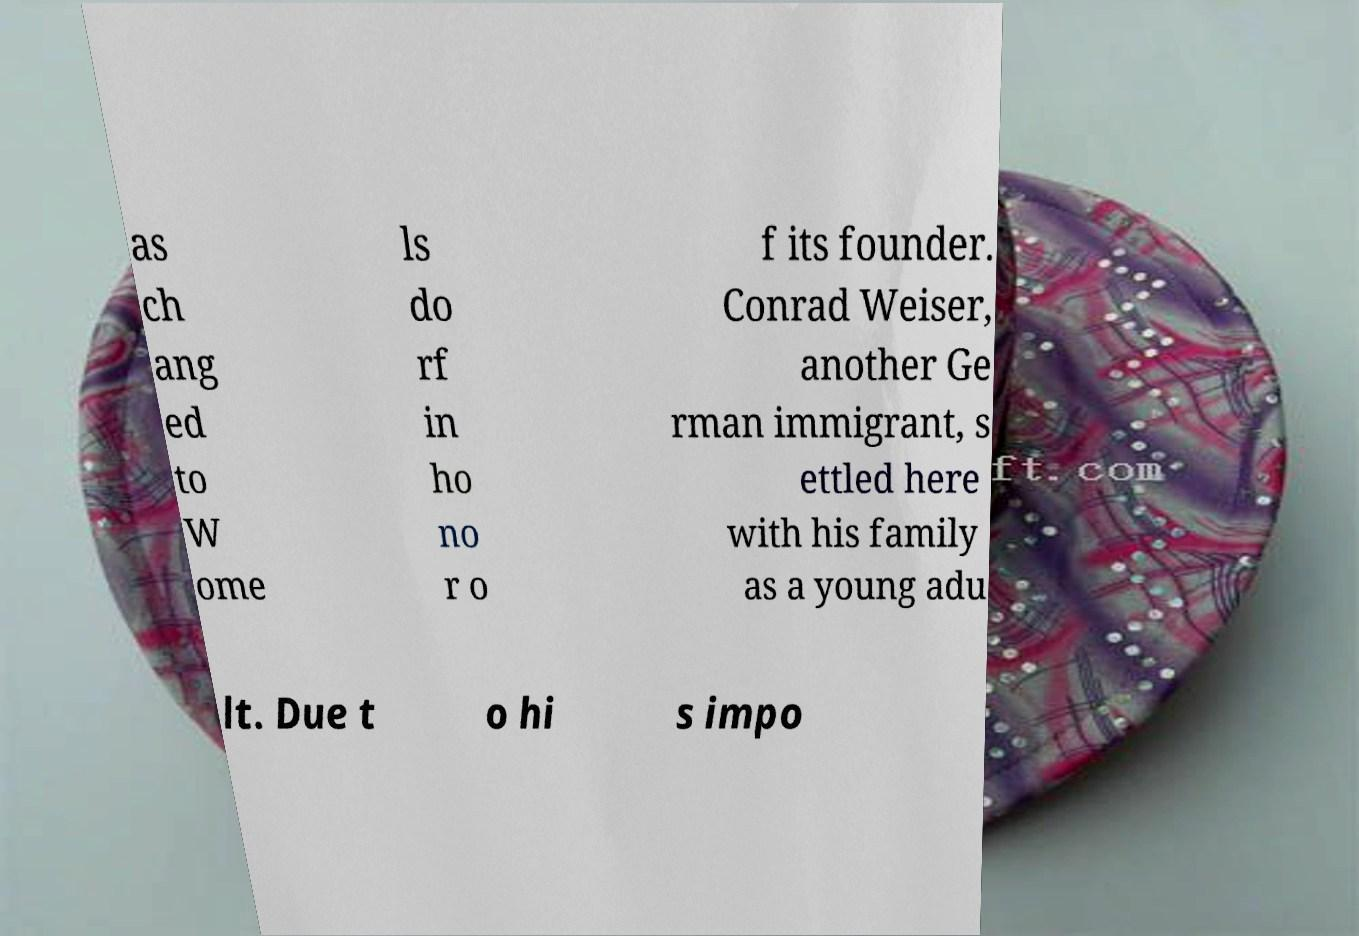For documentation purposes, I need the text within this image transcribed. Could you provide that? as ch ang ed to W ome ls do rf in ho no r o f its founder. Conrad Weiser, another Ge rman immigrant, s ettled here with his family as a young adu lt. Due t o hi s impo 